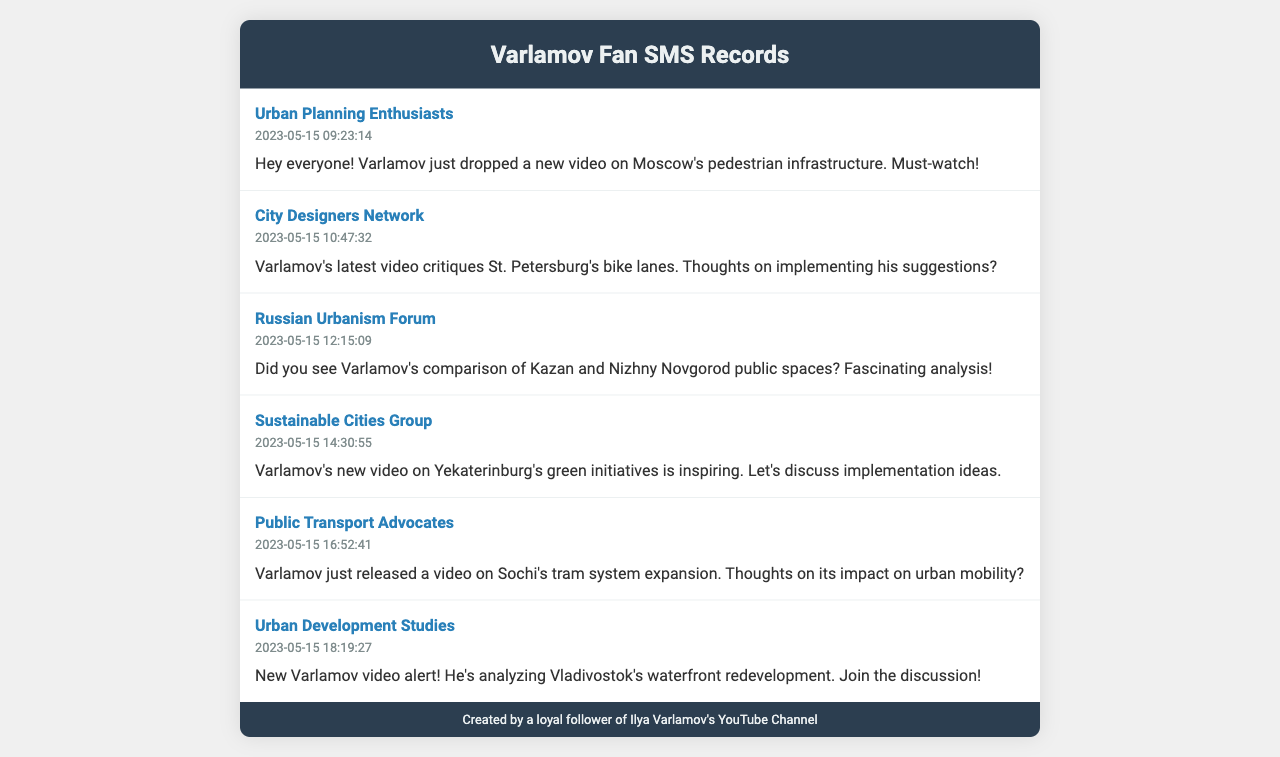What is the timestamp of the first SMS message? The first SMS message was sent at the timestamp provided, which is 2023-05-15 09:23:14.
Answer: 2023-05-15 09:23:14 Who is the recipient of the second SMS message? The second SMS message is directed towards the "City Designers Network."
Answer: City Designers Network What is the main topic of Varlamov's video mentioned in the fourth SMS? The fourth SMS discusses Varlamov's video on Yekaterinburg's green initiatives, indicating a focus on sustainability.
Answer: Yekaterinburg's green initiatives How many SMS messages were sent overall? The document lists a total of six SMS messages that were sent.
Answer: 6 What is a common theme discussed in the SMS messages? Each SMS discusses topics related to urban planning and improvement, connected to Varlamov's videos.
Answer: Urban planning Which group received a message about tram system expansion? The message regarding tram system expansion was sent to the "Public Transport Advocates."
Answer: Public Transport Advocates What was the time difference between the first and last SMS messages? The last SMS was sent at 2023-05-15 18:19:27, which is a difference of 9 hours and 6 minutes from the first, which was at 09:23:14.
Answer: 9 hours and 6 minutes 